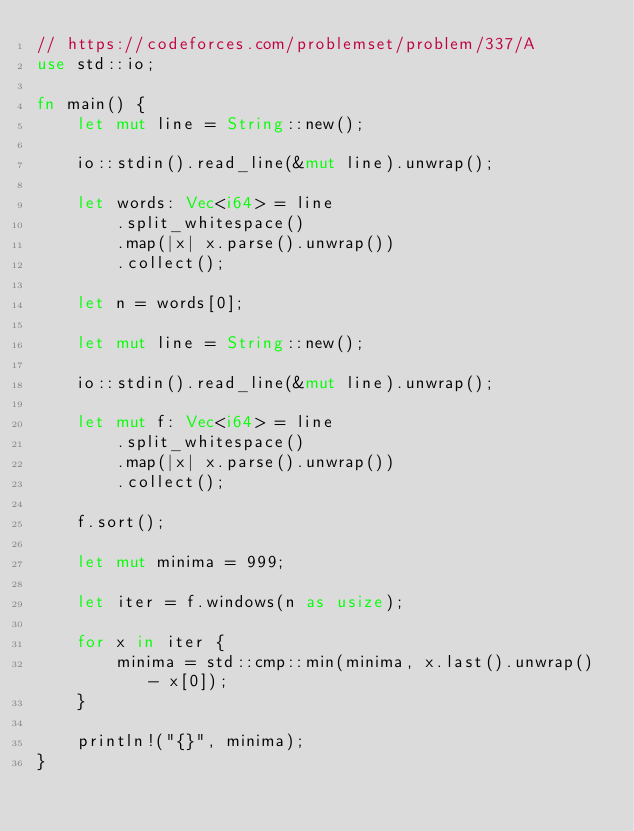<code> <loc_0><loc_0><loc_500><loc_500><_Rust_>// https://codeforces.com/problemset/problem/337/A
use std::io;

fn main() {
    let mut line = String::new();

    io::stdin().read_line(&mut line).unwrap();

    let words: Vec<i64> = line
        .split_whitespace()
        .map(|x| x.parse().unwrap())
        .collect();

    let n = words[0];

    let mut line = String::new();

    io::stdin().read_line(&mut line).unwrap();

    let mut f: Vec<i64> = line
        .split_whitespace()
        .map(|x| x.parse().unwrap())
        .collect();

    f.sort();

    let mut minima = 999;

    let iter = f.windows(n as usize);

    for x in iter {
        minima = std::cmp::min(minima, x.last().unwrap() - x[0]);
    }

    println!("{}", minima);
}

</code> 